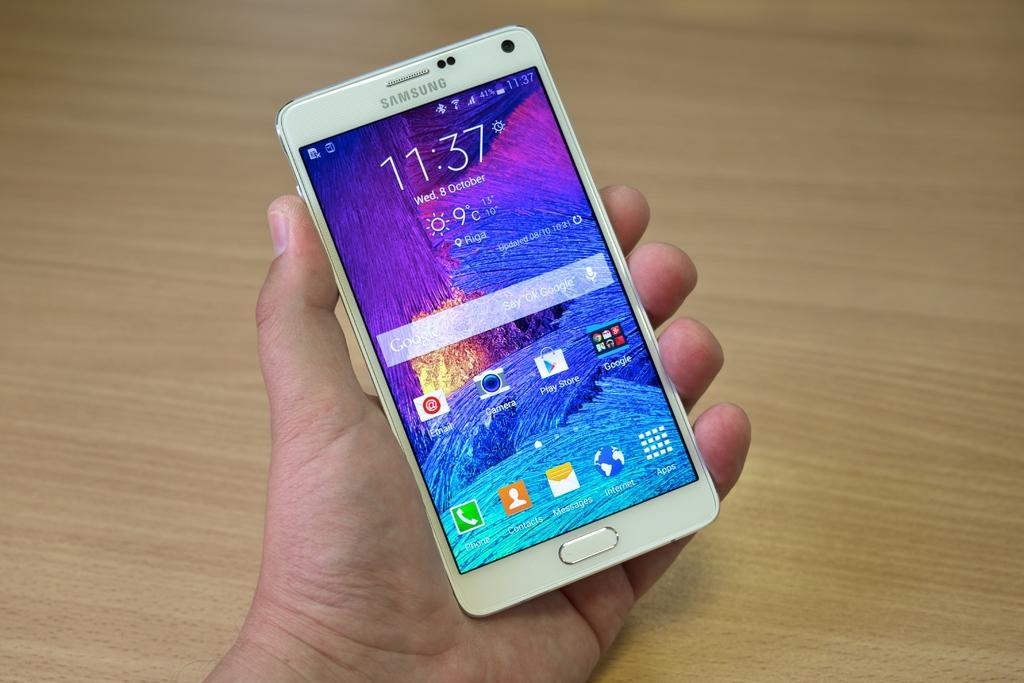<image>
Render a clear and concise summary of the photo. Samsung cell phone with the time of 11:37 in white on the front. 